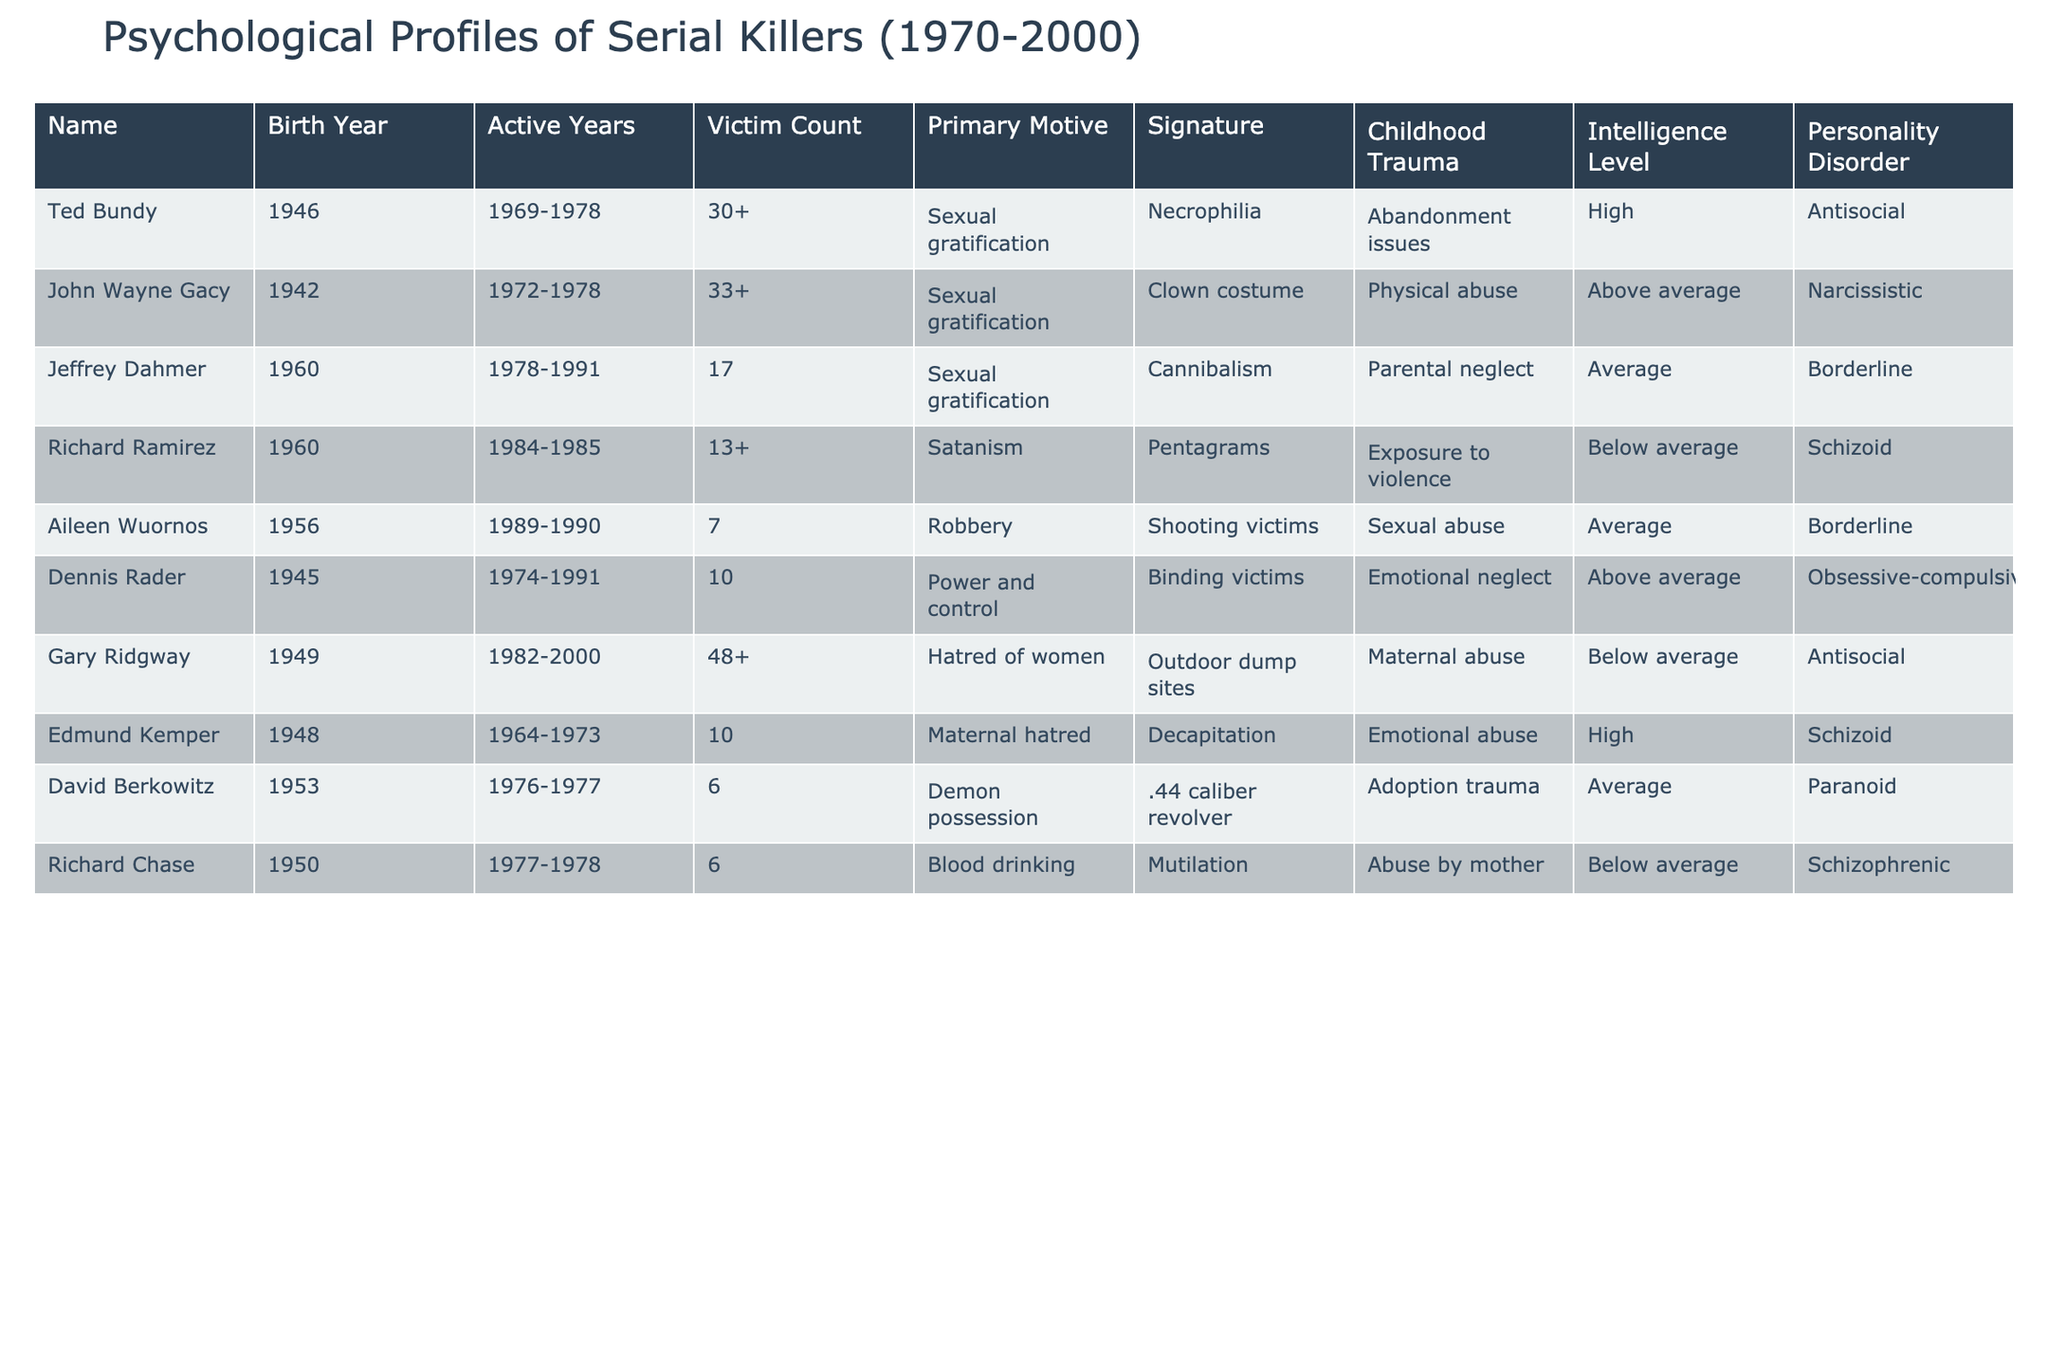What is the primary motive for Jeffrey Dahmer? The table lists Jeffrey Dahmer's primary motive as "Sexual gratification."
Answer: Sexual gratification How many victims did Gary Ridgway have? According to the table, Gary Ridgway has an active years range of 1982-2000 and is listed with 48+ victims.
Answer: 48+ Which serial killer had a personality disorder classified as paranoid? The table indicates David Berkowitz is classified as having a paranoid personality disorder.
Answer: David Berkowitz What is the childhood trauma experienced by Ted Bundy? The table specifies that Ted Bundy experienced abandonment issues during childhood.
Answer: Abandonment issues How many serial killers listed had below average intelligence? By reviewing the table, Richard Ramirez, Gary Ridgway, and Richard Chase are noted to have below average intelligence, totaling three killers.
Answer: 3 Which motive is associated with Aileen Wuornos? The table shows that Aileen Wuornos had a motive of robbery.
Answer: Robbery Is there anyone in the table with a median victim count of more than 15? Analyzing the data, both Gary Ridgway (48+) and Ted Bundy (30+) have a victim count over 15, confirming that there are individuals with that characteristic.
Answer: Yes What commonality do Dennis Rader and John Wayne Gacy share in terms of victim count? Both Dennis Rader and John Wayne Gacy have victim counts of 10+ and 33+ respectively. Their victim counts are all over 10, showing a similarity.
Answer: Both have victim counts over 10 Which serial killer had the highest intelligence level? The table indicates that both Ted Bundy and Edmund Kemper have high intelligence levels, which is the highest category listed.
Answer: Ted Bundy and Edmund Kemper What is the signature act of Richard Chase? The table states that Richard Chase's signature act involved mutilation.
Answer: Mutilation How many killers are associated with the motive of sexual gratification? By counting the entries in the table, four killers (Ted Bundy, John Wayne Gacy, Jeffrey Dahmer, Aileen Wuornos) are associated with sexual gratification.
Answer: 4 What percentage of the listed serial killers experienced childhood trauma? There are 10 serial killers in the table, and 8 of them experienced some form of childhood trauma. Therefore, (8/10)*100 = 80%.
Answer: 80% Which killer used a .44 caliber revolver? According to the table, David Berkowitz is noted for using a .44 caliber revolver.
Answer: David Berkowitz What is the relationship between childhood trauma and personality disorder in the case of Dennis Rader? Dennis Rader experienced emotional neglect in childhood and has an obsessive-compulsive personality disorder, thus indicating a possible link between his background and disorder.
Answer: Emotional neglect and obsessive-compulsive disorder Which serial killer had a signature that included cannibalism? The table specifies that Jeffrey Dahmer's signature involved cannibalism.
Answer: Jeffrey Dahmer How does Richard Ramirez's victim count compare to Aileen Wuornos's? Richard Ramirez has a victim count of 13+ while Aileen Wuornos has 7, so Richard Ramirez has more victims than Aileen Wuornos.
Answer: Richard Ramirez has more victims 